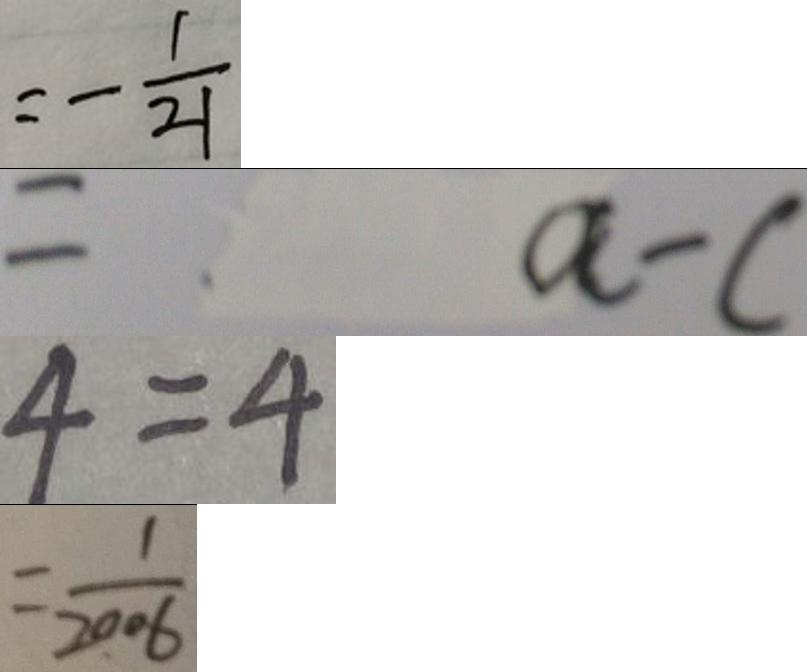Convert formula to latex. <formula><loc_0><loc_0><loc_500><loc_500>= - \frac { 1 } { 2 1 } 
 = a - c 
 4 = 4 
 = \frac { 1 } { 2 0 0 6 }</formula> 